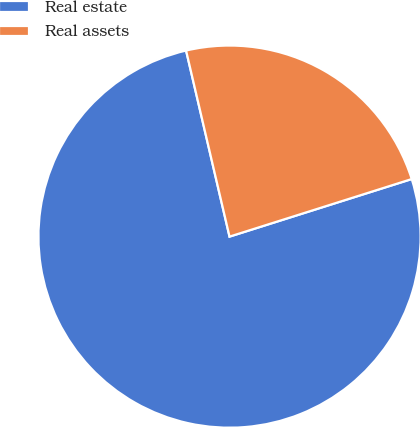<chart> <loc_0><loc_0><loc_500><loc_500><pie_chart><fcel>Real estate<fcel>Real assets<nl><fcel>76.22%<fcel>23.78%<nl></chart> 